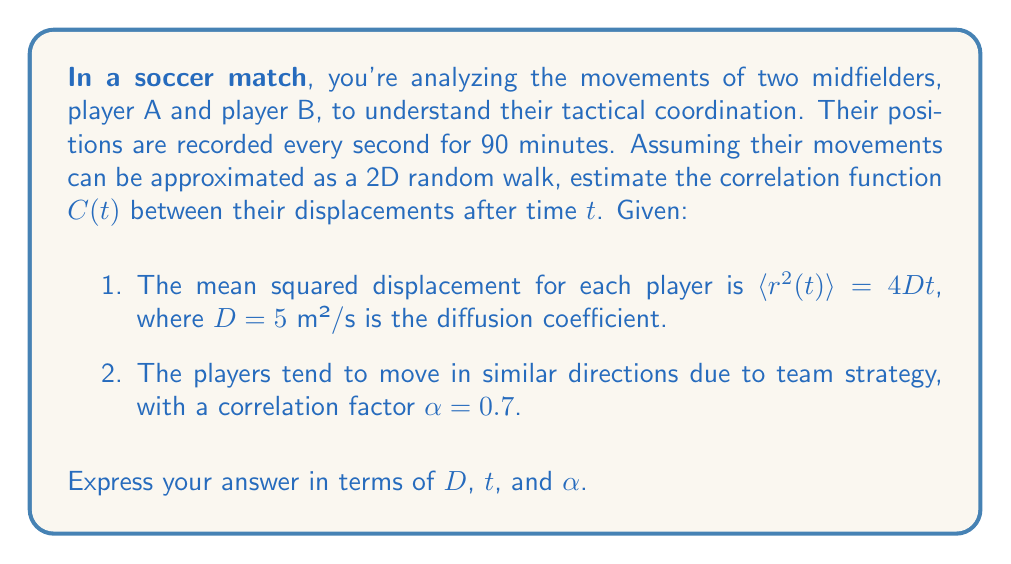Give your solution to this math problem. To estimate the correlation function between the player movements, we'll follow these steps:

1) In statistical mechanics, the correlation function for two particles undergoing correlated random walks can be expressed as:

   $$C(t) = \langle \mathbf{r}_A(t) \cdot \mathbf{r}_B(t) \rangle$$

   where $\mathbf{r}_A(t)$ and $\mathbf{r}_B(t)$ are the displacement vectors of players A and B after time $t$.

2) For correlated random walks, we can express this as:

   $$C(t) = \alpha \langle r^2(t) \rangle$$

   where $\alpha$ is the correlation factor and $\langle r^2(t) \rangle$ is the mean squared displacement.

3) We're given that $\langle r^2(t) \rangle = 4Dt$, where $D = 5$ m²/s.

4) Substituting this into our correlation function:

   $$C(t) = \alpha (4Dt)$$

5) Now, we can substitute the given values:

   $$C(t) = 0.7 (4 \cdot 5 \text{ m²/s} \cdot t)$$

6) Simplifying:

   $$C(t) = 14t \text{ m²}$$

This gives us the correlation function in terms of $D$, $t$, and $\alpha$.
Answer: $C(t) = 14t \text{ m²}$ 